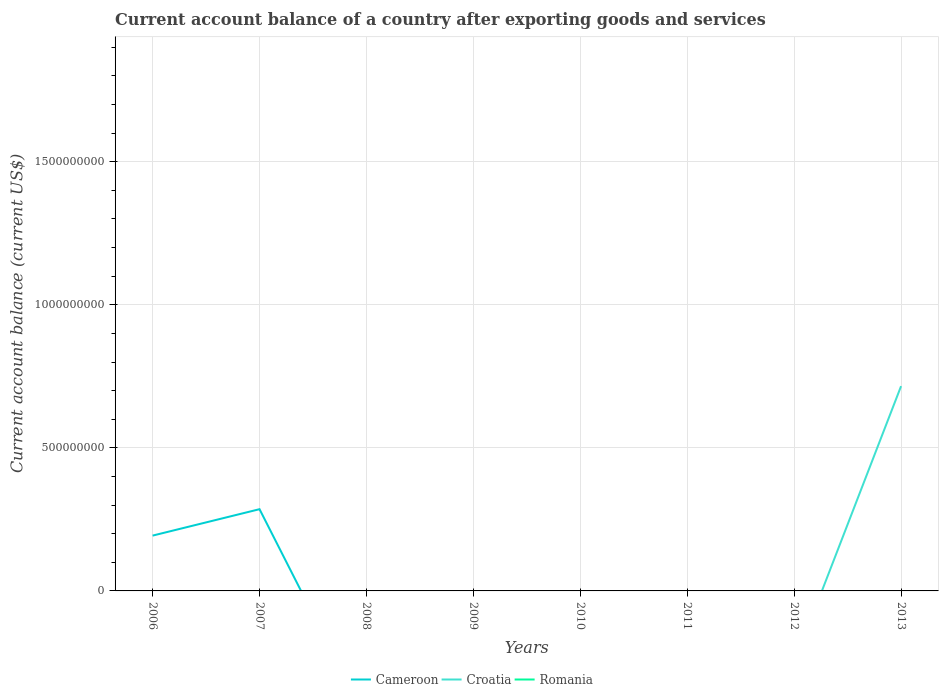Does the line corresponding to Romania intersect with the line corresponding to Croatia?
Ensure brevity in your answer.  No. Across all years, what is the maximum account balance in Cameroon?
Make the answer very short. 0. What is the difference between the highest and the second highest account balance in Cameroon?
Give a very brief answer. 2.86e+08. What is the difference between the highest and the lowest account balance in Romania?
Provide a short and direct response. 0. Is the account balance in Romania strictly greater than the account balance in Croatia over the years?
Give a very brief answer. Yes. How many years are there in the graph?
Your answer should be compact. 8. What is the difference between two consecutive major ticks on the Y-axis?
Provide a short and direct response. 5.00e+08. How many legend labels are there?
Ensure brevity in your answer.  3. What is the title of the graph?
Give a very brief answer. Current account balance of a country after exporting goods and services. Does "Libya" appear as one of the legend labels in the graph?
Give a very brief answer. No. What is the label or title of the Y-axis?
Provide a short and direct response. Current account balance (current US$). What is the Current account balance (current US$) in Cameroon in 2006?
Provide a succinct answer. 1.93e+08. What is the Current account balance (current US$) of Cameroon in 2007?
Offer a very short reply. 2.86e+08. What is the Current account balance (current US$) in Croatia in 2007?
Your answer should be very brief. 0. What is the Current account balance (current US$) of Cameroon in 2009?
Provide a succinct answer. 0. What is the Current account balance (current US$) in Romania in 2009?
Ensure brevity in your answer.  0. What is the Current account balance (current US$) of Cameroon in 2011?
Your response must be concise. 0. What is the Current account balance (current US$) in Croatia in 2011?
Offer a very short reply. 0. What is the Current account balance (current US$) of Romania in 2011?
Your answer should be very brief. 0. What is the Current account balance (current US$) in Cameroon in 2012?
Make the answer very short. 0. What is the Current account balance (current US$) of Cameroon in 2013?
Your response must be concise. 0. What is the Current account balance (current US$) in Croatia in 2013?
Keep it short and to the point. 7.16e+08. What is the Current account balance (current US$) in Romania in 2013?
Offer a terse response. 0. Across all years, what is the maximum Current account balance (current US$) in Cameroon?
Your answer should be compact. 2.86e+08. Across all years, what is the maximum Current account balance (current US$) of Croatia?
Give a very brief answer. 7.16e+08. What is the total Current account balance (current US$) of Cameroon in the graph?
Keep it short and to the point. 4.79e+08. What is the total Current account balance (current US$) in Croatia in the graph?
Provide a succinct answer. 7.16e+08. What is the total Current account balance (current US$) in Romania in the graph?
Offer a very short reply. 0. What is the difference between the Current account balance (current US$) of Cameroon in 2006 and that in 2007?
Make the answer very short. -9.24e+07. What is the difference between the Current account balance (current US$) in Cameroon in 2006 and the Current account balance (current US$) in Croatia in 2013?
Provide a short and direct response. -5.22e+08. What is the difference between the Current account balance (current US$) of Cameroon in 2007 and the Current account balance (current US$) of Croatia in 2013?
Make the answer very short. -4.30e+08. What is the average Current account balance (current US$) of Cameroon per year?
Make the answer very short. 5.99e+07. What is the average Current account balance (current US$) of Croatia per year?
Provide a succinct answer. 8.95e+07. What is the average Current account balance (current US$) of Romania per year?
Offer a terse response. 0. What is the ratio of the Current account balance (current US$) in Cameroon in 2006 to that in 2007?
Your answer should be compact. 0.68. What is the difference between the highest and the lowest Current account balance (current US$) in Cameroon?
Provide a short and direct response. 2.86e+08. What is the difference between the highest and the lowest Current account balance (current US$) in Croatia?
Make the answer very short. 7.16e+08. 